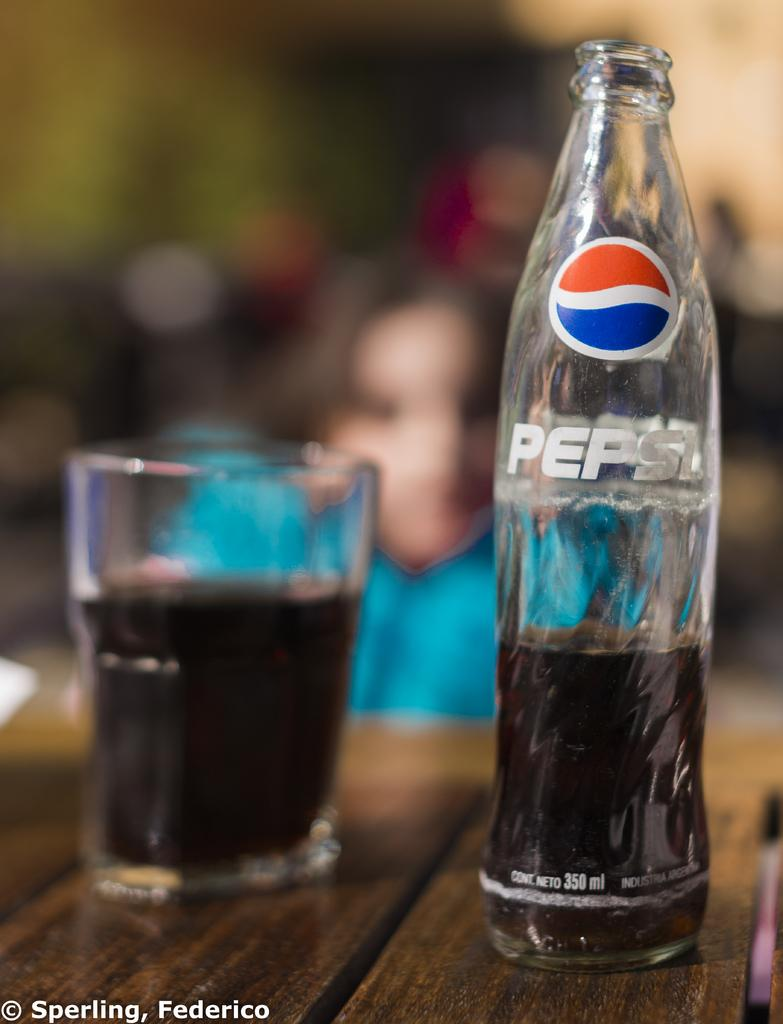<image>
Write a terse but informative summary of the picture. A bottle of Pepsi is half empty and stands next to a glass. 